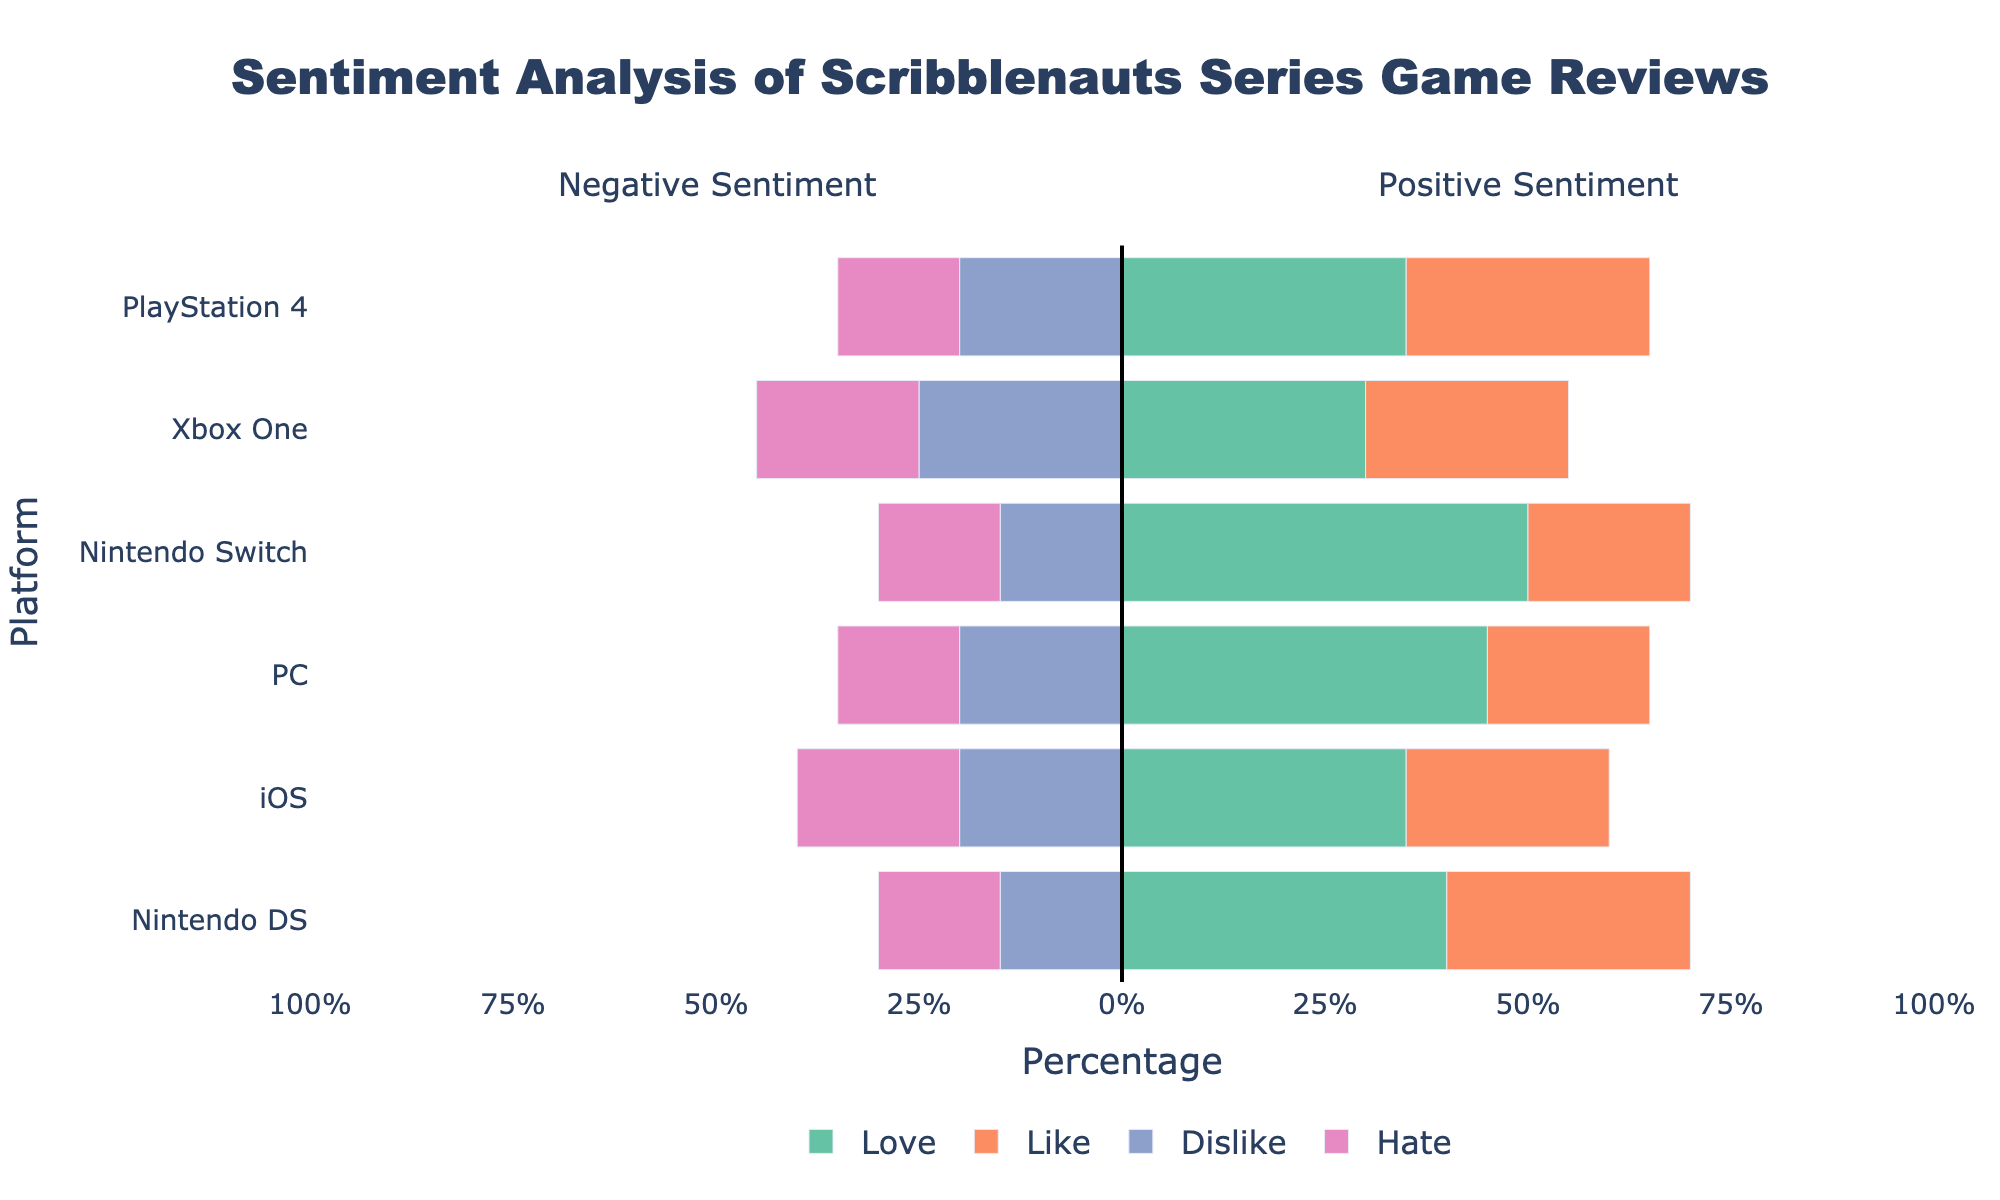What platform has the highest percentage of "Love" sentiment? We look at the bars representing the "Love" sentiment for each platform. The Nintendo Switch has the highest "Love" percentage at 50%.
Answer: Nintendo Switch Which platform has more "Dislike" reviews: iOS or Xbox One? We compare the "Dislike" bars for iOS and Xbox One. iOS has a "Dislike" percentage of 20%, while Xbox One has 25%.
Answer: Xbox One What is the total positive sentiment (Love + Like) percentage for PlayStation 4? We add the "Love" (35%) and "Like" (30%) percentages for PlayStation 4. 35% + 30% = 65%.
Answer: 65% Which platform has the lowest percentage of "Hate" reviews? We compare the "Hate" bars across all platforms. Both Nintendo DS, Nintendo Switch, and PlayStation 4 have the lowest "Hate" percentage at 15%.
Answer: Nintendo DS, Nintendo Switch, PlayStation 4 Does the PC have more positive reviews (Love + Like) or negative reviews (Dislike + Hate)? We add the "Love" (45%) and "Like" (20%) percentages for positives (45% + 20% = 65%), then the "Dislike" (20%) and "Hate" (15%) percentages for negatives (20% + 15% = 35%). Positive reviews (65%) are more than negative reviews (35%).
Answer: Positive reviews Which platform has the most balanced sentiment between positive and negative? We compare the platforms by evaluating the difference between positive (Love + Like) and negative (Dislike + Hate) percentages. Xbox One has the closest balance: Positive (30%+25%) = 55%, Negative (25%+20%) = 45%, so the difference is 10%. Other platforms have larger differences.
Answer: Xbox One What is the average percentage of "Love" sentiment across all platforms? We add the "Love" percentages across all platforms and divide by the number of platforms: (40% + 35% + 45% + 50% + 30% + 35%) / 6. The total is 235%, so average is 235% / 6 ≈ 39.17%.
Answer: 39.17% Which sentiment has the widest variance in percentages across platforms? We look at the range of percentages for each sentiment. "Love" ranges from 30% to 50% (20% variance), "Like" from 20% to 30% (10% variance), "Dislike" from 15% to 25% (10% variance), and "Hate" from 15% to 20% (5% variance). Therefore, "Love" has the widest variance.
Answer: Love Is the sum of negative reviews (Dislike + Hate) greater on the Nintendo DS or iOS? We calculate and compare the sums: Nintendo DS (15%+15%) = 30%, iOS (20%+20%) = 40%. So, iOS has a higher sum of negative reviews.
Answer: iOS 